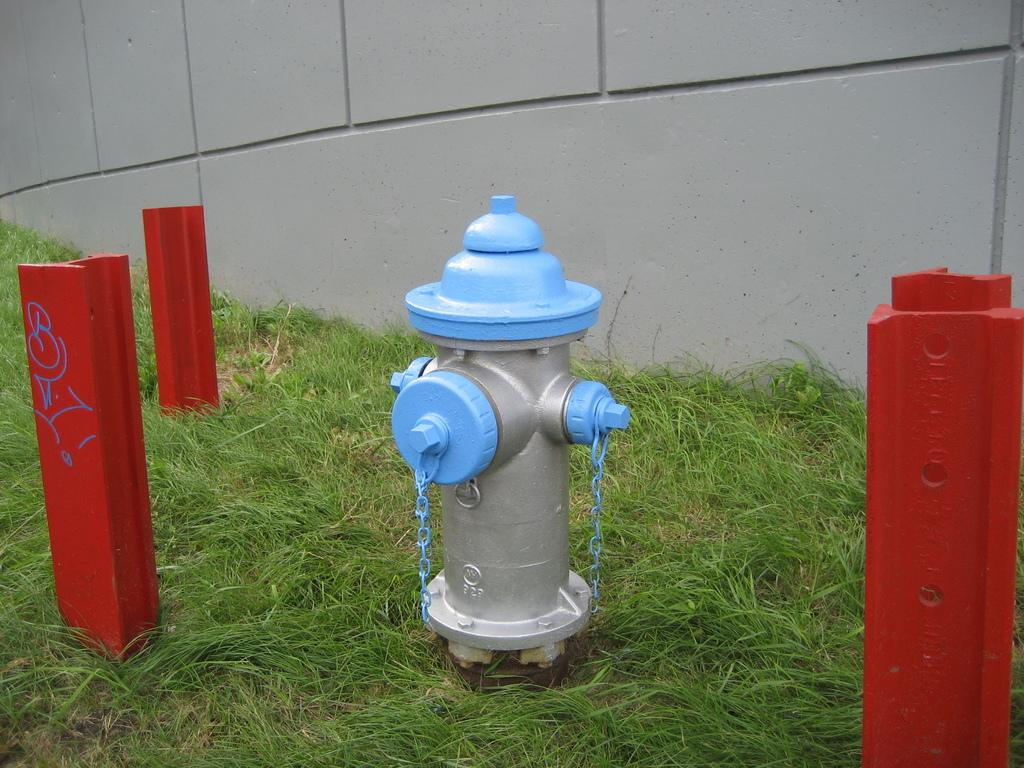What object is the main focus of the image? There is a hydrant in the image. What type of vegetation can be seen in the image? There is grass in the image. What structures are present in the image? There are poles visible in the image. What can be seen in the background of the image? There is a wall visible in the background of the image. What advice is the hydrant giving to the mountain in the image? There is no mountain present in the image, and the hydrant is an inanimate object, so it cannot give advice. 